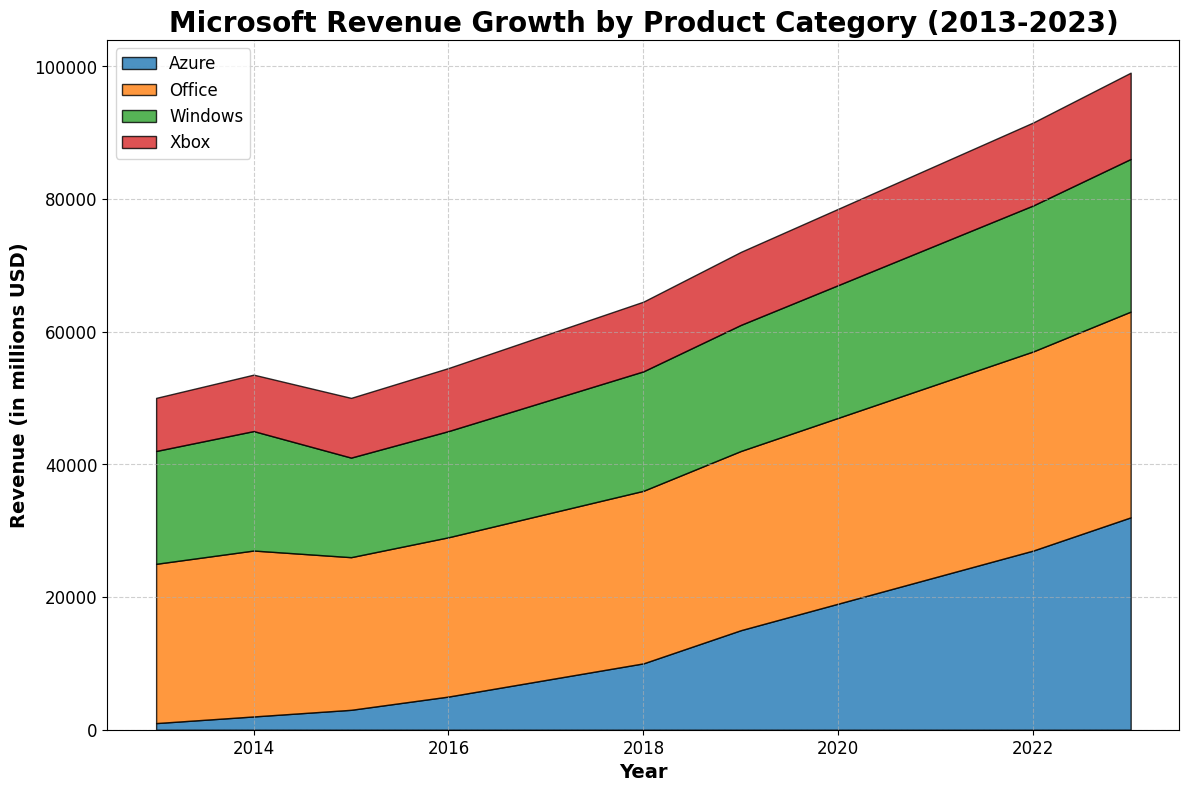What year did Azure surpass Xbox in revenue? In the figure, observe the relative sizes of the areas representing Azure and Xbox revenues for each year. In 2016, Azure's revenue (5000) surpasses Xbox's revenue (9500). Therefore, look for the year where this relationship changes. By 2019, Azure (15000) is clearly ahead of Xbox (11000).
Answer: 2019 Which product category showed the most consistent revenue growth over the period? Examine the trends for each product category from 2013 to 2023. Office shows a consistent upward trend without any noticeable drops or plateaus over the entire period.
Answer: Office What's the total combined revenue for all product categories in 2020? Add the revenues of all product categories for the year 2020: Windows (20000) + Office (28000) + Azure (19000) + Xbox (11500) = 78500.
Answer: 78500 By comparing the market share visually, which product category had the highest peak revenue and in what year? Look at the height of the areas for each product category. Office appears to be the tallest in 2023. The peak revenue for Office is 31000 in 2023.
Answer: Office, 2023 How did the revenue of Windows in 2013 compare to Windows in 2023? The revenue for Windows in 2013 was 17000 and in 2023 it is 23000. Compare 23000 to 17000 which shows an increase.
Answer: Increased by 6000 Between which two consecutive years did Azure see the highest revenue jump? Check Azure's area year by year and note the largest increase. The highest jump is between 2022 (27000) and 2023 (32000), which is 5000.
Answer: 2022 to 2023 Which year did all product categories (Windows, Office, Azure, Xbox) show an increase in revenue? Inspect each year's revenue increments visually. In 2023, all categories (Windows, Office, Azure, and Xbox) show an increase compared to 2022.
Answer: 2023 How does the revenue trend of Xbox compare to that of Windows over the period 2013-2023? Analyze the overall pattern for Xbox and Windows. Both show an upward trend, but Windows has a larger revenue base and more noticeable increases. Xbox’s growth is steadier but less pronounced than Windows' trend lines.
Answer: Windows shows more significant growth but both increase Is there any year in which the revenue for either Office or Windows decreased? Observe the shapes for the Office and Windows areas. Office shows no decrease, while Windows decreased between 2014 (18000) and 2015 (15000).
Answer: Windows decreased in 2015 